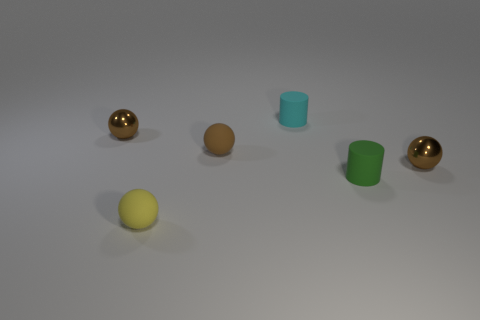What number of objects are either big cyan objects or small metallic objects?
Offer a terse response. 2. The small brown shiny thing in front of the ball that is behind the brown rubber object is what shape?
Ensure brevity in your answer.  Sphere. What number of other things are there of the same material as the tiny green thing
Your answer should be very brief. 3. Do the yellow sphere and the small cylinder that is to the right of the small cyan rubber thing have the same material?
Offer a terse response. Yes. What number of objects are shiny objects to the right of the yellow rubber ball or small brown metal objects right of the green matte cylinder?
Offer a very short reply. 1. Are there more tiny matte balls that are behind the cyan rubber cylinder than tiny cyan rubber objects in front of the yellow thing?
Provide a succinct answer. No. What number of cylinders are either cyan rubber objects or tiny metal objects?
Ensure brevity in your answer.  1. What number of things are brown objects left of the yellow matte object or cyan matte cylinders?
Your answer should be very brief. 2. What is the shape of the object that is behind the metal thing that is behind the tiny brown metallic object on the right side of the yellow matte ball?
Give a very brief answer. Cylinder. What number of other green objects are the same shape as the green object?
Offer a very short reply. 0. 